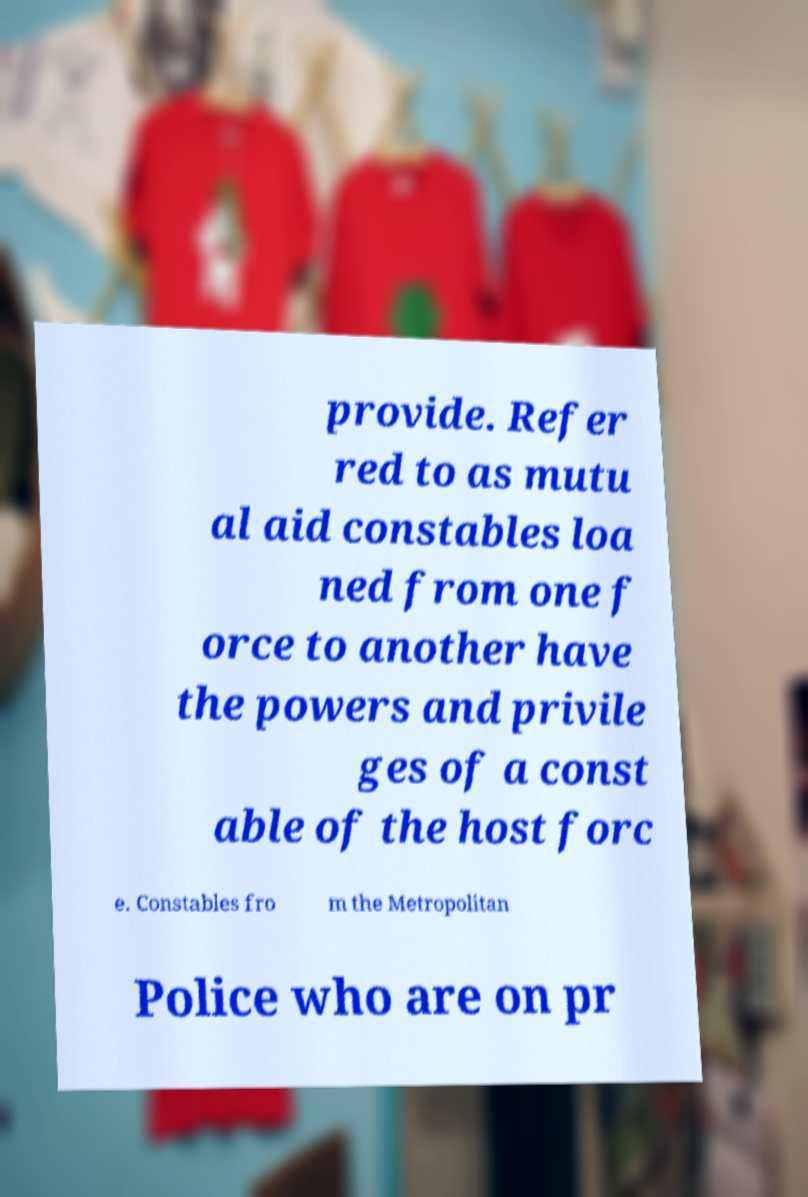For documentation purposes, I need the text within this image transcribed. Could you provide that? provide. Refer red to as mutu al aid constables loa ned from one f orce to another have the powers and privile ges of a const able of the host forc e. Constables fro m the Metropolitan Police who are on pr 